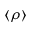<formula> <loc_0><loc_0><loc_500><loc_500>\langle \rho \rangle</formula> 